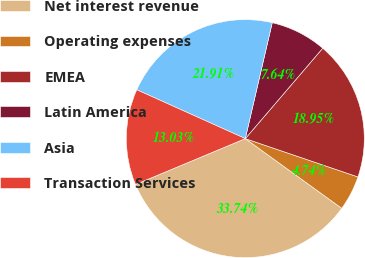Convert chart to OTSL. <chart><loc_0><loc_0><loc_500><loc_500><pie_chart><fcel>Net interest revenue<fcel>Operating expenses<fcel>EMEA<fcel>Latin America<fcel>Asia<fcel>Transaction Services<nl><fcel>33.75%<fcel>4.74%<fcel>18.95%<fcel>7.64%<fcel>21.91%<fcel>13.03%<nl></chart> 